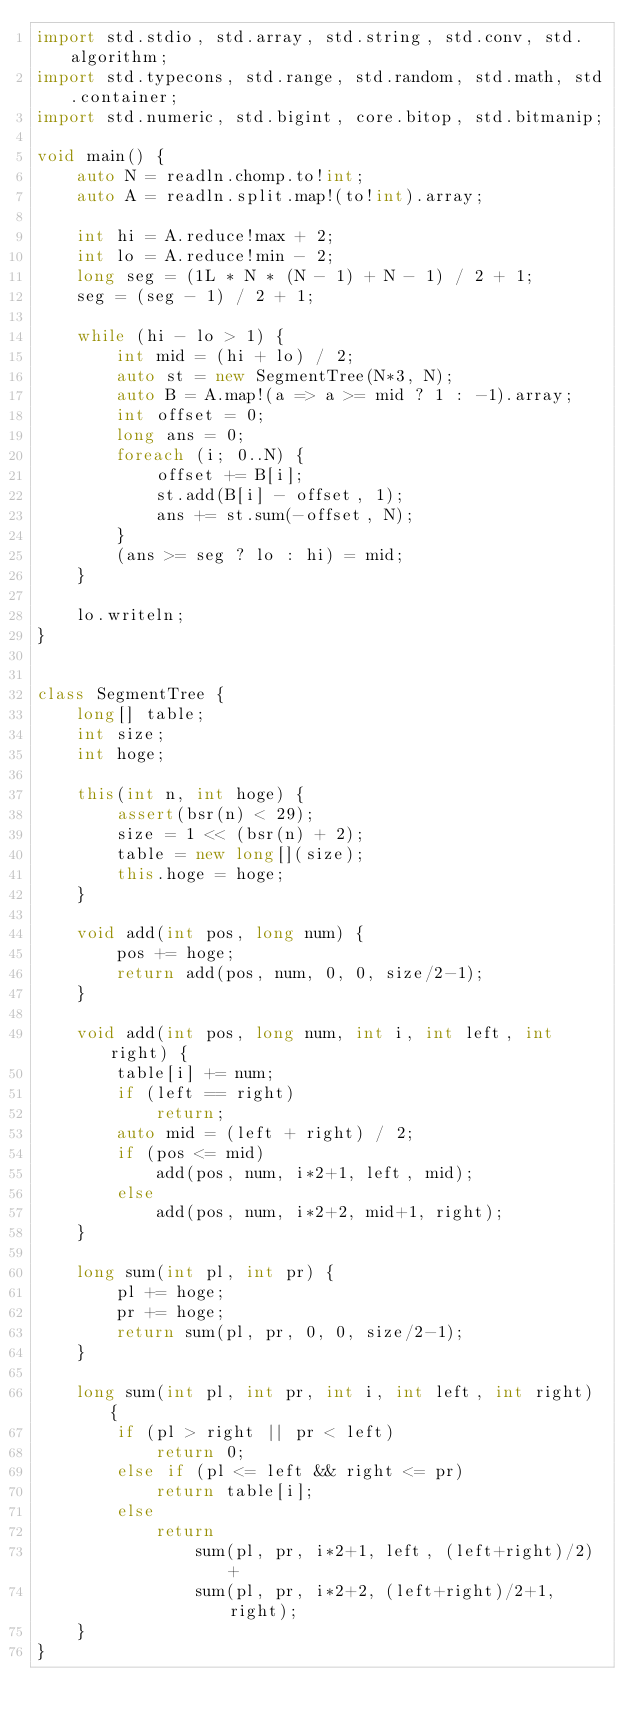<code> <loc_0><loc_0><loc_500><loc_500><_D_>import std.stdio, std.array, std.string, std.conv, std.algorithm;
import std.typecons, std.range, std.random, std.math, std.container;
import std.numeric, std.bigint, core.bitop, std.bitmanip;

void main() {
    auto N = readln.chomp.to!int;
    auto A = readln.split.map!(to!int).array;

    int hi = A.reduce!max + 2;
    int lo = A.reduce!min - 2;
    long seg = (1L * N * (N - 1) + N - 1) / 2 + 1;
    seg = (seg - 1) / 2 + 1;

    while (hi - lo > 1) {
        int mid = (hi + lo) / 2;
        auto st = new SegmentTree(N*3, N);
        auto B = A.map!(a => a >= mid ? 1 : -1).array;
        int offset = 0;
        long ans = 0;
        foreach (i; 0..N) {
            offset += B[i];
            st.add(B[i] - offset, 1);
            ans += st.sum(-offset, N);
        }
        (ans >= seg ? lo : hi) = mid;
    }

    lo.writeln;
}


class SegmentTree {
    long[] table;
    int size;
    int hoge;

    this(int n, int hoge) {
        assert(bsr(n) < 29);
        size = 1 << (bsr(n) + 2);
        table = new long[](size);
        this.hoge = hoge;
    }

    void add(int pos, long num) {
        pos += hoge;
        return add(pos, num, 0, 0, size/2-1);
    }

    void add(int pos, long num, int i, int left, int right) {
        table[i] += num;
        if (left == right)
            return;
        auto mid = (left + right) / 2;
        if (pos <= mid)
            add(pos, num, i*2+1, left, mid);
        else
            add(pos, num, i*2+2, mid+1, right);
    }

    long sum(int pl, int pr) {
        pl += hoge;
        pr += hoge;
        return sum(pl, pr, 0, 0, size/2-1);
    }

    long sum(int pl, int pr, int i, int left, int right) {
        if (pl > right || pr < left)
            return 0;
        else if (pl <= left && right <= pr)
            return table[i];
        else
            return
                sum(pl, pr, i*2+1, left, (left+right)/2) +
                sum(pl, pr, i*2+2, (left+right)/2+1, right);
    }
}
</code> 